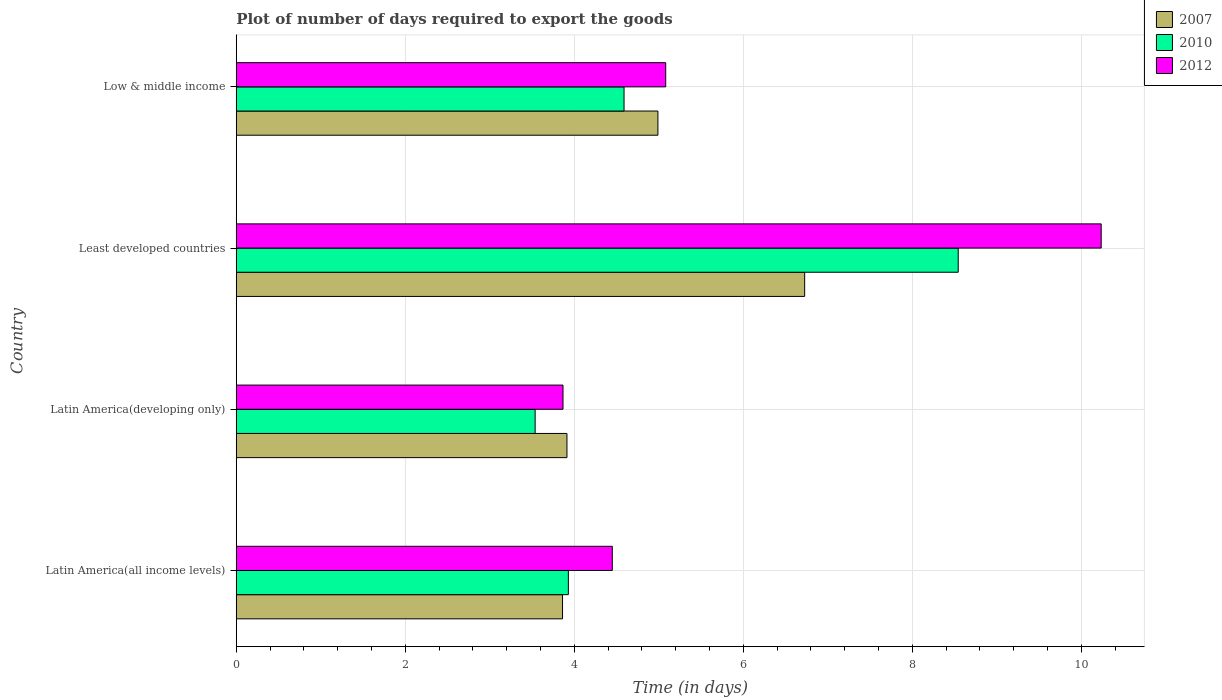How many different coloured bars are there?
Your response must be concise. 3. How many groups of bars are there?
Offer a very short reply. 4. Are the number of bars on each tick of the Y-axis equal?
Provide a short and direct response. Yes. How many bars are there on the 1st tick from the bottom?
Give a very brief answer. 3. What is the label of the 2nd group of bars from the top?
Provide a succinct answer. Least developed countries. What is the time required to export goods in 2010 in Latin America(developing only)?
Your response must be concise. 3.54. Across all countries, what is the maximum time required to export goods in 2007?
Provide a succinct answer. 6.73. Across all countries, what is the minimum time required to export goods in 2012?
Your answer should be very brief. 3.87. In which country was the time required to export goods in 2012 maximum?
Keep it short and to the point. Least developed countries. In which country was the time required to export goods in 2007 minimum?
Ensure brevity in your answer.  Latin America(all income levels). What is the total time required to export goods in 2012 in the graph?
Your answer should be very brief. 23.63. What is the difference between the time required to export goods in 2012 in Latin America(all income levels) and that in Latin America(developing only)?
Keep it short and to the point. 0.58. What is the difference between the time required to export goods in 2010 in Low & middle income and the time required to export goods in 2007 in Least developed countries?
Your response must be concise. -2.14. What is the average time required to export goods in 2012 per country?
Ensure brevity in your answer.  5.91. What is the difference between the time required to export goods in 2007 and time required to export goods in 2012 in Latin America(all income levels)?
Your answer should be very brief. -0.59. What is the ratio of the time required to export goods in 2010 in Latin America(all income levels) to that in Least developed countries?
Provide a succinct answer. 0.46. Is the time required to export goods in 2010 in Latin America(developing only) less than that in Least developed countries?
Your answer should be compact. Yes. What is the difference between the highest and the second highest time required to export goods in 2012?
Give a very brief answer. 5.15. What is the difference between the highest and the lowest time required to export goods in 2007?
Your answer should be compact. 2.87. What does the 3rd bar from the top in Latin America(all income levels) represents?
Ensure brevity in your answer.  2007. What does the 1st bar from the bottom in Least developed countries represents?
Provide a short and direct response. 2007. What is the difference between two consecutive major ticks on the X-axis?
Keep it short and to the point. 2. How are the legend labels stacked?
Your answer should be very brief. Vertical. What is the title of the graph?
Your response must be concise. Plot of number of days required to export the goods. Does "1996" appear as one of the legend labels in the graph?
Keep it short and to the point. No. What is the label or title of the X-axis?
Give a very brief answer. Time (in days). What is the label or title of the Y-axis?
Provide a succinct answer. Country. What is the Time (in days) of 2007 in Latin America(all income levels)?
Make the answer very short. 3.86. What is the Time (in days) of 2010 in Latin America(all income levels)?
Keep it short and to the point. 3.93. What is the Time (in days) of 2012 in Latin America(all income levels)?
Your answer should be very brief. 4.45. What is the Time (in days) in 2007 in Latin America(developing only)?
Keep it short and to the point. 3.91. What is the Time (in days) in 2010 in Latin America(developing only)?
Your response must be concise. 3.54. What is the Time (in days) in 2012 in Latin America(developing only)?
Your answer should be very brief. 3.87. What is the Time (in days) of 2007 in Least developed countries?
Make the answer very short. 6.73. What is the Time (in days) in 2010 in Least developed countries?
Your answer should be compact. 8.54. What is the Time (in days) of 2012 in Least developed countries?
Keep it short and to the point. 10.24. What is the Time (in days) of 2007 in Low & middle income?
Make the answer very short. 4.99. What is the Time (in days) of 2010 in Low & middle income?
Offer a terse response. 4.59. What is the Time (in days) of 2012 in Low & middle income?
Make the answer very short. 5.08. Across all countries, what is the maximum Time (in days) in 2007?
Give a very brief answer. 6.73. Across all countries, what is the maximum Time (in days) of 2010?
Ensure brevity in your answer.  8.54. Across all countries, what is the maximum Time (in days) in 2012?
Give a very brief answer. 10.24. Across all countries, what is the minimum Time (in days) in 2007?
Offer a very short reply. 3.86. Across all countries, what is the minimum Time (in days) in 2010?
Your answer should be very brief. 3.54. Across all countries, what is the minimum Time (in days) of 2012?
Your answer should be very brief. 3.87. What is the total Time (in days) in 2007 in the graph?
Offer a very short reply. 19.49. What is the total Time (in days) in 2010 in the graph?
Keep it short and to the point. 20.6. What is the total Time (in days) of 2012 in the graph?
Offer a terse response. 23.63. What is the difference between the Time (in days) of 2007 in Latin America(all income levels) and that in Latin America(developing only)?
Provide a succinct answer. -0.05. What is the difference between the Time (in days) in 2010 in Latin America(all income levels) and that in Latin America(developing only)?
Keep it short and to the point. 0.39. What is the difference between the Time (in days) in 2012 in Latin America(all income levels) and that in Latin America(developing only)?
Give a very brief answer. 0.58. What is the difference between the Time (in days) of 2007 in Latin America(all income levels) and that in Least developed countries?
Offer a very short reply. -2.87. What is the difference between the Time (in days) in 2010 in Latin America(all income levels) and that in Least developed countries?
Your answer should be compact. -4.61. What is the difference between the Time (in days) in 2012 in Latin America(all income levels) and that in Least developed countries?
Your answer should be compact. -5.79. What is the difference between the Time (in days) in 2007 in Latin America(all income levels) and that in Low & middle income?
Make the answer very short. -1.13. What is the difference between the Time (in days) in 2010 in Latin America(all income levels) and that in Low & middle income?
Make the answer very short. -0.66. What is the difference between the Time (in days) in 2012 in Latin America(all income levels) and that in Low & middle income?
Make the answer very short. -0.63. What is the difference between the Time (in days) of 2007 in Latin America(developing only) and that in Least developed countries?
Give a very brief answer. -2.81. What is the difference between the Time (in days) of 2010 in Latin America(developing only) and that in Least developed countries?
Offer a terse response. -5.01. What is the difference between the Time (in days) of 2012 in Latin America(developing only) and that in Least developed countries?
Your answer should be very brief. -6.37. What is the difference between the Time (in days) of 2007 in Latin America(developing only) and that in Low & middle income?
Your answer should be very brief. -1.08. What is the difference between the Time (in days) in 2010 in Latin America(developing only) and that in Low & middle income?
Your answer should be very brief. -1.05. What is the difference between the Time (in days) in 2012 in Latin America(developing only) and that in Low & middle income?
Your answer should be very brief. -1.22. What is the difference between the Time (in days) of 2007 in Least developed countries and that in Low & middle income?
Provide a short and direct response. 1.74. What is the difference between the Time (in days) of 2010 in Least developed countries and that in Low & middle income?
Offer a very short reply. 3.95. What is the difference between the Time (in days) of 2012 in Least developed countries and that in Low & middle income?
Make the answer very short. 5.15. What is the difference between the Time (in days) in 2007 in Latin America(all income levels) and the Time (in days) in 2010 in Latin America(developing only)?
Provide a short and direct response. 0.32. What is the difference between the Time (in days) in 2007 in Latin America(all income levels) and the Time (in days) in 2012 in Latin America(developing only)?
Ensure brevity in your answer.  -0.01. What is the difference between the Time (in days) of 2010 in Latin America(all income levels) and the Time (in days) of 2012 in Latin America(developing only)?
Your answer should be compact. 0.06. What is the difference between the Time (in days) of 2007 in Latin America(all income levels) and the Time (in days) of 2010 in Least developed countries?
Provide a succinct answer. -4.68. What is the difference between the Time (in days) in 2007 in Latin America(all income levels) and the Time (in days) in 2012 in Least developed countries?
Keep it short and to the point. -6.37. What is the difference between the Time (in days) of 2010 in Latin America(all income levels) and the Time (in days) of 2012 in Least developed countries?
Ensure brevity in your answer.  -6.31. What is the difference between the Time (in days) in 2007 in Latin America(all income levels) and the Time (in days) in 2010 in Low & middle income?
Provide a short and direct response. -0.73. What is the difference between the Time (in days) in 2007 in Latin America(all income levels) and the Time (in days) in 2012 in Low & middle income?
Give a very brief answer. -1.22. What is the difference between the Time (in days) in 2010 in Latin America(all income levels) and the Time (in days) in 2012 in Low & middle income?
Make the answer very short. -1.15. What is the difference between the Time (in days) of 2007 in Latin America(developing only) and the Time (in days) of 2010 in Least developed countries?
Make the answer very short. -4.63. What is the difference between the Time (in days) of 2007 in Latin America(developing only) and the Time (in days) of 2012 in Least developed countries?
Ensure brevity in your answer.  -6.32. What is the difference between the Time (in days) of 2010 in Latin America(developing only) and the Time (in days) of 2012 in Least developed countries?
Ensure brevity in your answer.  -6.7. What is the difference between the Time (in days) of 2007 in Latin America(developing only) and the Time (in days) of 2010 in Low & middle income?
Provide a succinct answer. -0.68. What is the difference between the Time (in days) of 2007 in Latin America(developing only) and the Time (in days) of 2012 in Low & middle income?
Provide a short and direct response. -1.17. What is the difference between the Time (in days) in 2010 in Latin America(developing only) and the Time (in days) in 2012 in Low & middle income?
Give a very brief answer. -1.55. What is the difference between the Time (in days) in 2007 in Least developed countries and the Time (in days) in 2010 in Low & middle income?
Offer a very short reply. 2.14. What is the difference between the Time (in days) in 2007 in Least developed countries and the Time (in days) in 2012 in Low & middle income?
Make the answer very short. 1.64. What is the difference between the Time (in days) in 2010 in Least developed countries and the Time (in days) in 2012 in Low & middle income?
Your answer should be compact. 3.46. What is the average Time (in days) of 2007 per country?
Provide a short and direct response. 4.87. What is the average Time (in days) of 2010 per country?
Give a very brief answer. 5.15. What is the average Time (in days) of 2012 per country?
Make the answer very short. 5.91. What is the difference between the Time (in days) of 2007 and Time (in days) of 2010 in Latin America(all income levels)?
Make the answer very short. -0.07. What is the difference between the Time (in days) of 2007 and Time (in days) of 2012 in Latin America(all income levels)?
Provide a short and direct response. -0.59. What is the difference between the Time (in days) in 2010 and Time (in days) in 2012 in Latin America(all income levels)?
Your answer should be compact. -0.52. What is the difference between the Time (in days) in 2007 and Time (in days) in 2010 in Latin America(developing only)?
Give a very brief answer. 0.38. What is the difference between the Time (in days) of 2007 and Time (in days) of 2012 in Latin America(developing only)?
Make the answer very short. 0.05. What is the difference between the Time (in days) of 2010 and Time (in days) of 2012 in Latin America(developing only)?
Provide a succinct answer. -0.33. What is the difference between the Time (in days) of 2007 and Time (in days) of 2010 in Least developed countries?
Give a very brief answer. -1.82. What is the difference between the Time (in days) in 2007 and Time (in days) in 2012 in Least developed countries?
Give a very brief answer. -3.51. What is the difference between the Time (in days) of 2010 and Time (in days) of 2012 in Least developed countries?
Offer a very short reply. -1.69. What is the difference between the Time (in days) of 2007 and Time (in days) of 2010 in Low & middle income?
Offer a very short reply. 0.4. What is the difference between the Time (in days) in 2007 and Time (in days) in 2012 in Low & middle income?
Your answer should be very brief. -0.09. What is the difference between the Time (in days) of 2010 and Time (in days) of 2012 in Low & middle income?
Provide a succinct answer. -0.49. What is the ratio of the Time (in days) in 2007 in Latin America(all income levels) to that in Latin America(developing only)?
Offer a terse response. 0.99. What is the ratio of the Time (in days) in 2010 in Latin America(all income levels) to that in Latin America(developing only)?
Your answer should be very brief. 1.11. What is the ratio of the Time (in days) in 2012 in Latin America(all income levels) to that in Latin America(developing only)?
Offer a terse response. 1.15. What is the ratio of the Time (in days) in 2007 in Latin America(all income levels) to that in Least developed countries?
Offer a very short reply. 0.57. What is the ratio of the Time (in days) of 2010 in Latin America(all income levels) to that in Least developed countries?
Provide a succinct answer. 0.46. What is the ratio of the Time (in days) of 2012 in Latin America(all income levels) to that in Least developed countries?
Provide a short and direct response. 0.43. What is the ratio of the Time (in days) of 2007 in Latin America(all income levels) to that in Low & middle income?
Offer a very short reply. 0.77. What is the ratio of the Time (in days) in 2010 in Latin America(all income levels) to that in Low & middle income?
Make the answer very short. 0.86. What is the ratio of the Time (in days) in 2012 in Latin America(all income levels) to that in Low & middle income?
Offer a very short reply. 0.88. What is the ratio of the Time (in days) in 2007 in Latin America(developing only) to that in Least developed countries?
Make the answer very short. 0.58. What is the ratio of the Time (in days) in 2010 in Latin America(developing only) to that in Least developed countries?
Make the answer very short. 0.41. What is the ratio of the Time (in days) of 2012 in Latin America(developing only) to that in Least developed countries?
Your response must be concise. 0.38. What is the ratio of the Time (in days) in 2007 in Latin America(developing only) to that in Low & middle income?
Your answer should be very brief. 0.78. What is the ratio of the Time (in days) in 2010 in Latin America(developing only) to that in Low & middle income?
Provide a succinct answer. 0.77. What is the ratio of the Time (in days) of 2012 in Latin America(developing only) to that in Low & middle income?
Offer a terse response. 0.76. What is the ratio of the Time (in days) of 2007 in Least developed countries to that in Low & middle income?
Offer a very short reply. 1.35. What is the ratio of the Time (in days) in 2010 in Least developed countries to that in Low & middle income?
Give a very brief answer. 1.86. What is the ratio of the Time (in days) in 2012 in Least developed countries to that in Low & middle income?
Offer a very short reply. 2.01. What is the difference between the highest and the second highest Time (in days) of 2007?
Your answer should be compact. 1.74. What is the difference between the highest and the second highest Time (in days) in 2010?
Provide a short and direct response. 3.95. What is the difference between the highest and the second highest Time (in days) in 2012?
Offer a very short reply. 5.15. What is the difference between the highest and the lowest Time (in days) in 2007?
Provide a succinct answer. 2.87. What is the difference between the highest and the lowest Time (in days) in 2010?
Keep it short and to the point. 5.01. What is the difference between the highest and the lowest Time (in days) of 2012?
Provide a succinct answer. 6.37. 